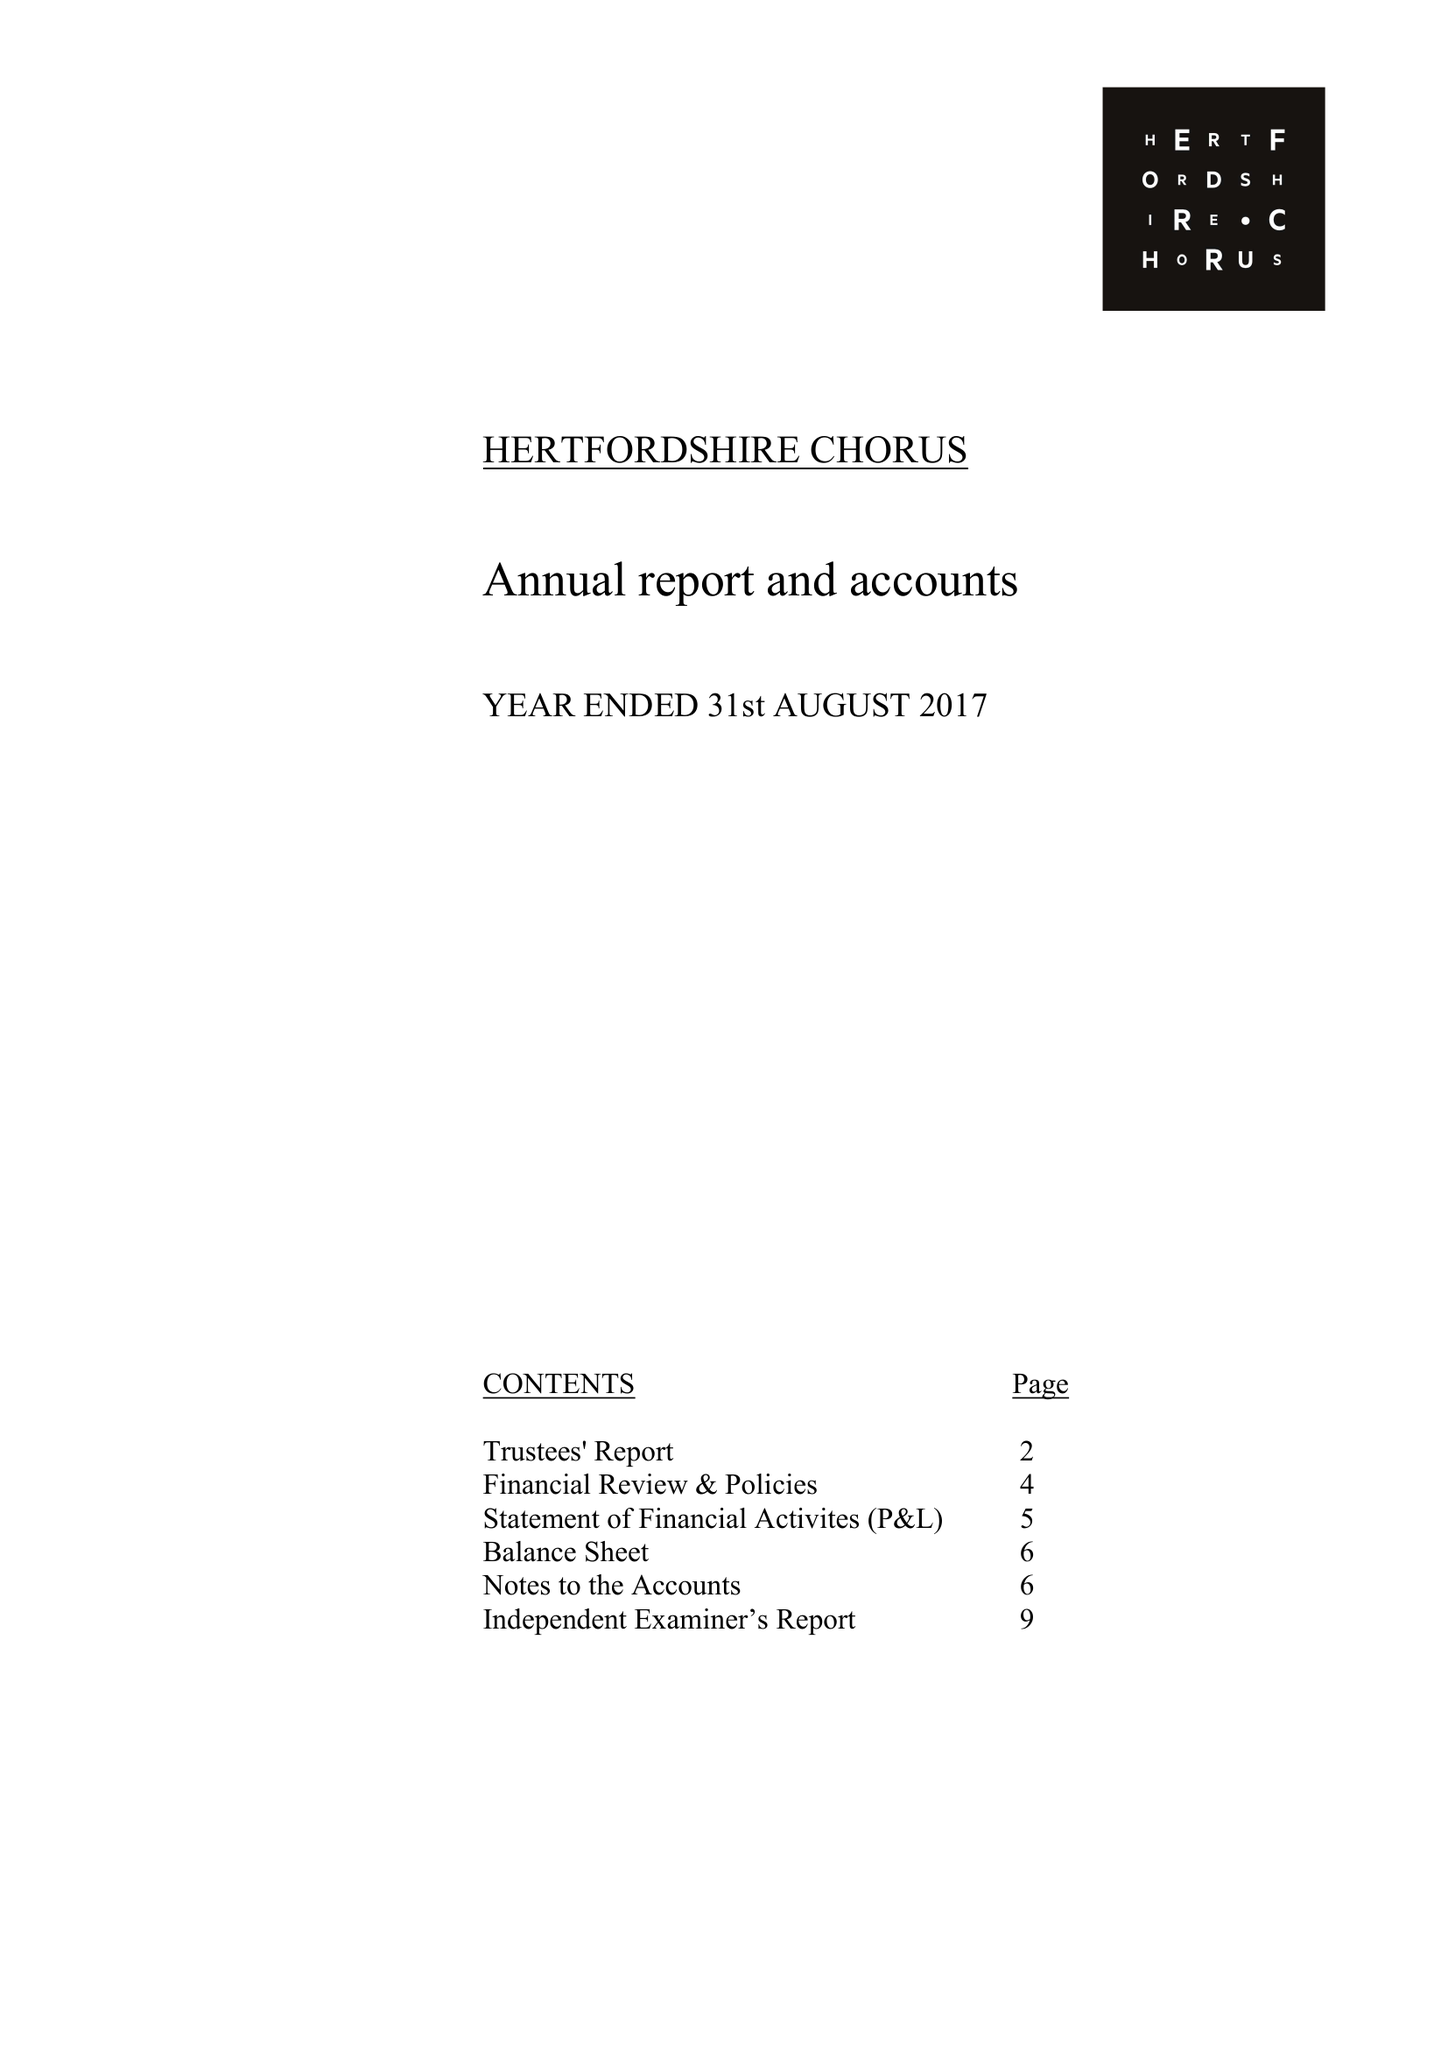What is the value for the spending_annually_in_british_pounds?
Answer the question using a single word or phrase. 119870.00 